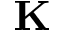<formula> <loc_0><loc_0><loc_500><loc_500>K</formula> 